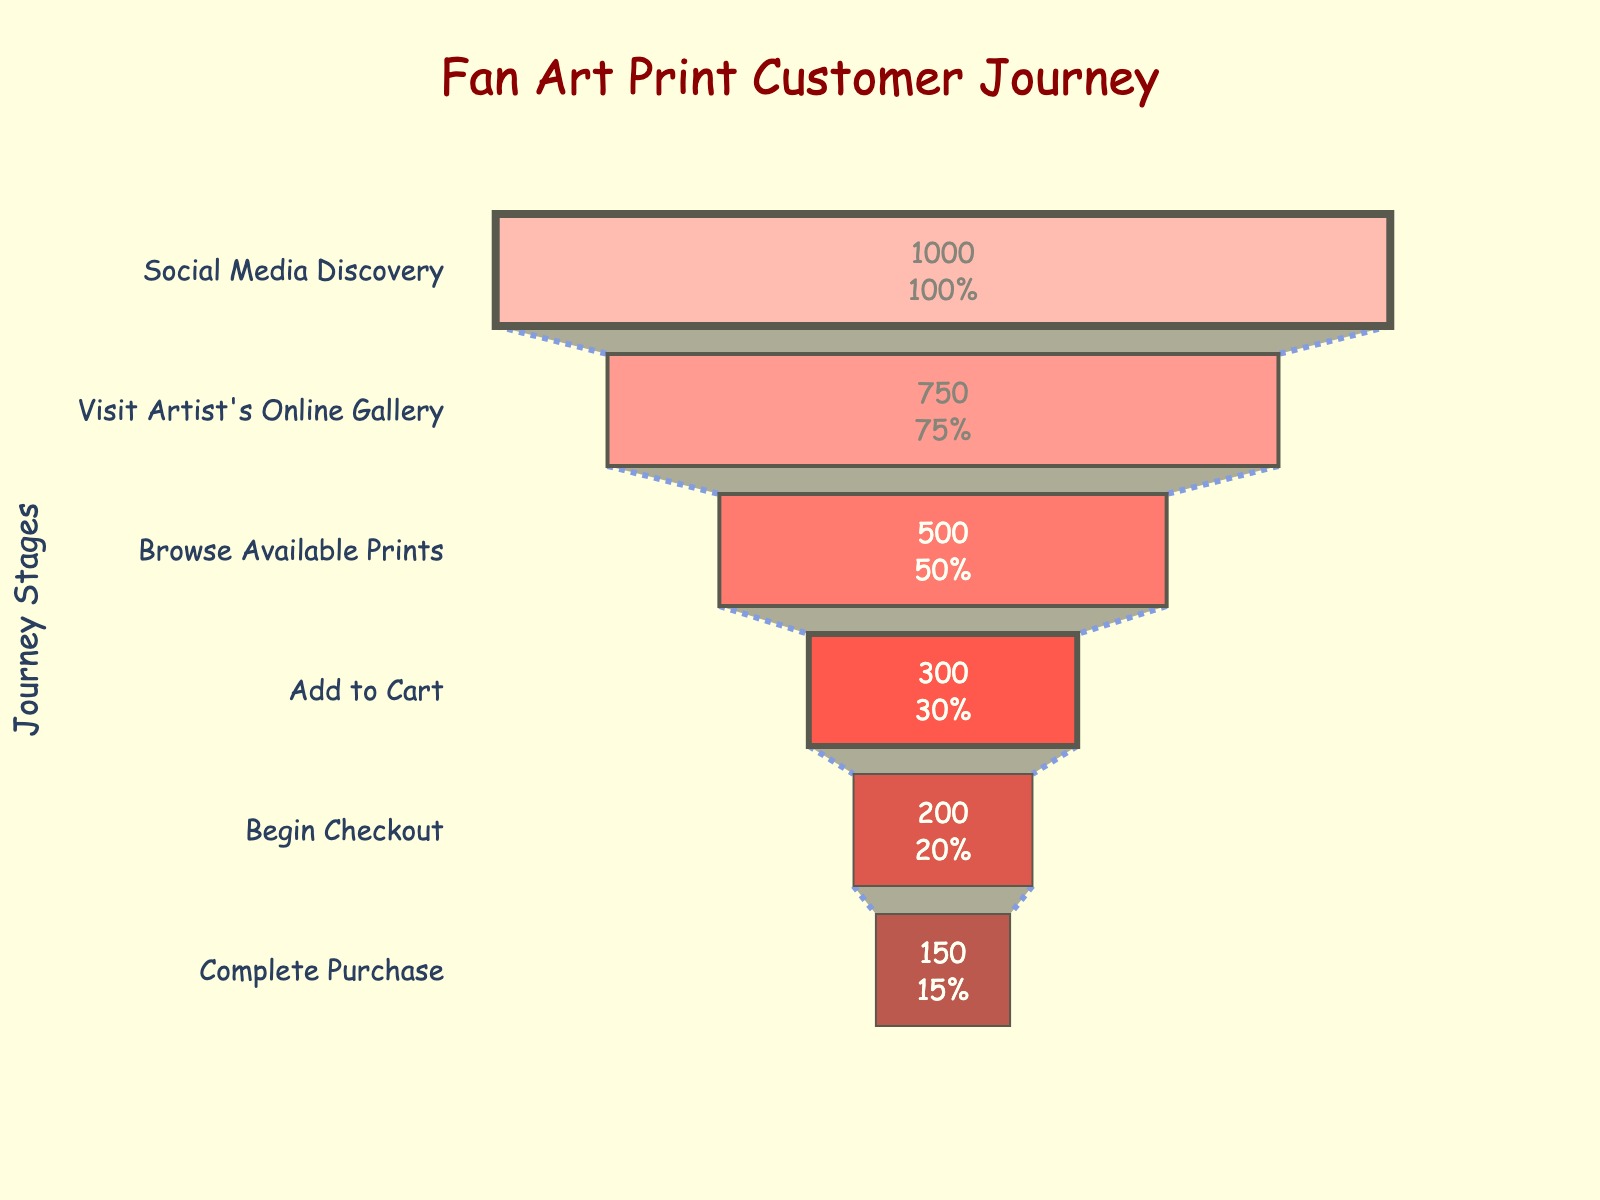How many stages are there in the customer journey? The figure has several horizontal bars representing different stages from "Social Media Discovery" to "Complete Purchase". Counting these bars, we get the total stages.
Answer: 6 What is the title of the figure? The title is usually displayed at the top of the figure. It reads "Fan Art Print Customer Journey".
Answer: Fan Art Print Customer Journey What percentage of customers visited the artist's online gallery after discovering on social media? Refer to the figure, locate the "Visit Artist's Online Gallery" stage and find the percentage related to the initial "Social Media Discovery" stage on the inside text of the bar.
Answer: 75% How many customers completed the purchase? Look at the final stage "Complete Purchase" and find the number displayed inside the bar.
Answer: 150 What is the difference in the number of customers between the "Browse Available Prints" and "Add to Cart" stages? Locate the "Browse Available Prints" stage (500 customers) and the "Add to Cart" stage (300 customers), then calculate the difference: 500 - 300.
Answer: 200 Which stage shows the highest decrease in customer numbers from the previous stage? By inspecting each successive stage, note the differences. The largest decrease is from "Social Media Discovery" (1000) to "Visit Artist's Online Gallery" (750), which is 250.
Answer: From "Social Media Discovery" to "Visit Artist's Online Gallery" How many customers dropped off between the "Begin Checkout" and "Complete Purchase" stages? Compare the number of customers at "Begin Checkout" (200) to those at "Complete Purchase" (150), then calculate the difference: 200 - 150.
Answer: 50 What percentage of customers who began checkout completed their purchase? Locate the "Begin Checkout" stage and "Complete Purchase" stage, then calculate the percentage 150/200 * 100.
Answer: 75% What is the color of the bar representing the "Visit Artist's Online Gallery" stage? Look at the color of the bar corresponding to "Visit Artist's Online Gallery" in the funnel chart, which is a specific shade of red.
Answer: Light Red How many customers dropped off between each stage? Compare each stage to the next:
Social Media Discovery (1000) to Visit Artist's Online Gallery (750), difference is 250,
Visit Artist's Online Gallery (750) to Browse Available Prints (500), difference is 250,
Browse Available Prints (500) to Add to Cart (300), difference is 200,
Add to Cart (300) to Begin Checkout (200), difference is 100,
Begin Checkout (200) to Complete Purchase (150), difference is 50. Summarize these values.
Answer: 250, 250, 200, 100, 50 